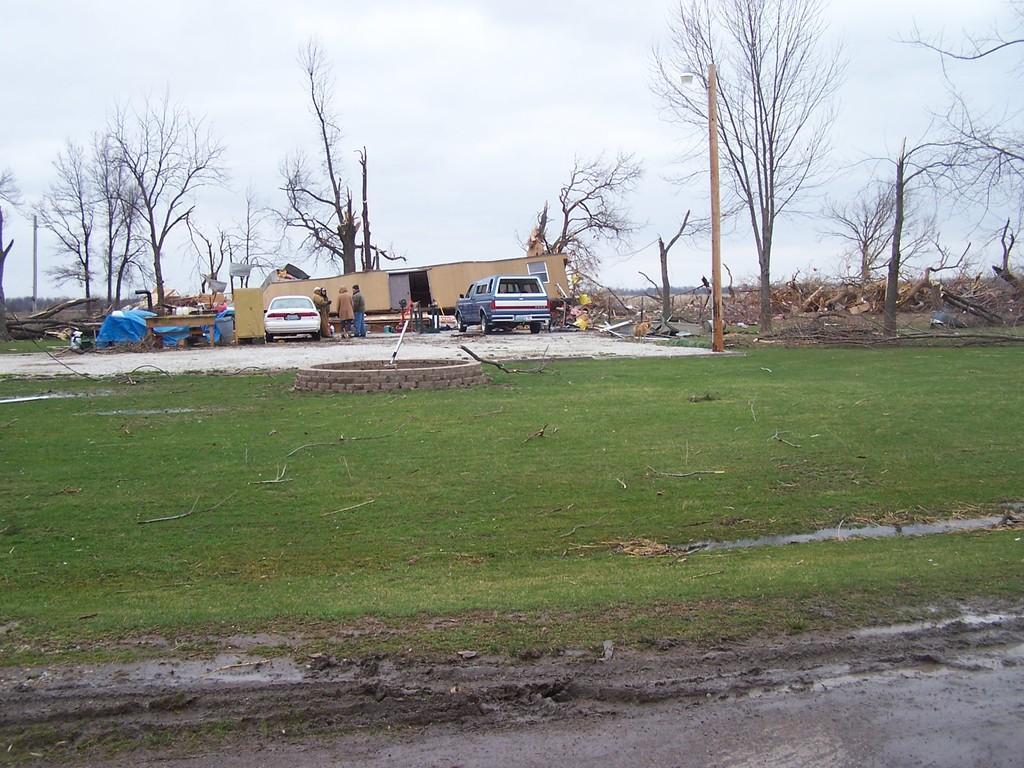How would you summarize this image in a sentence or two? In this image I can see few vehicles,dry trees,few people,wooden sticks,table,green grass and few objects on the ground. The sky is in white and blue color. 